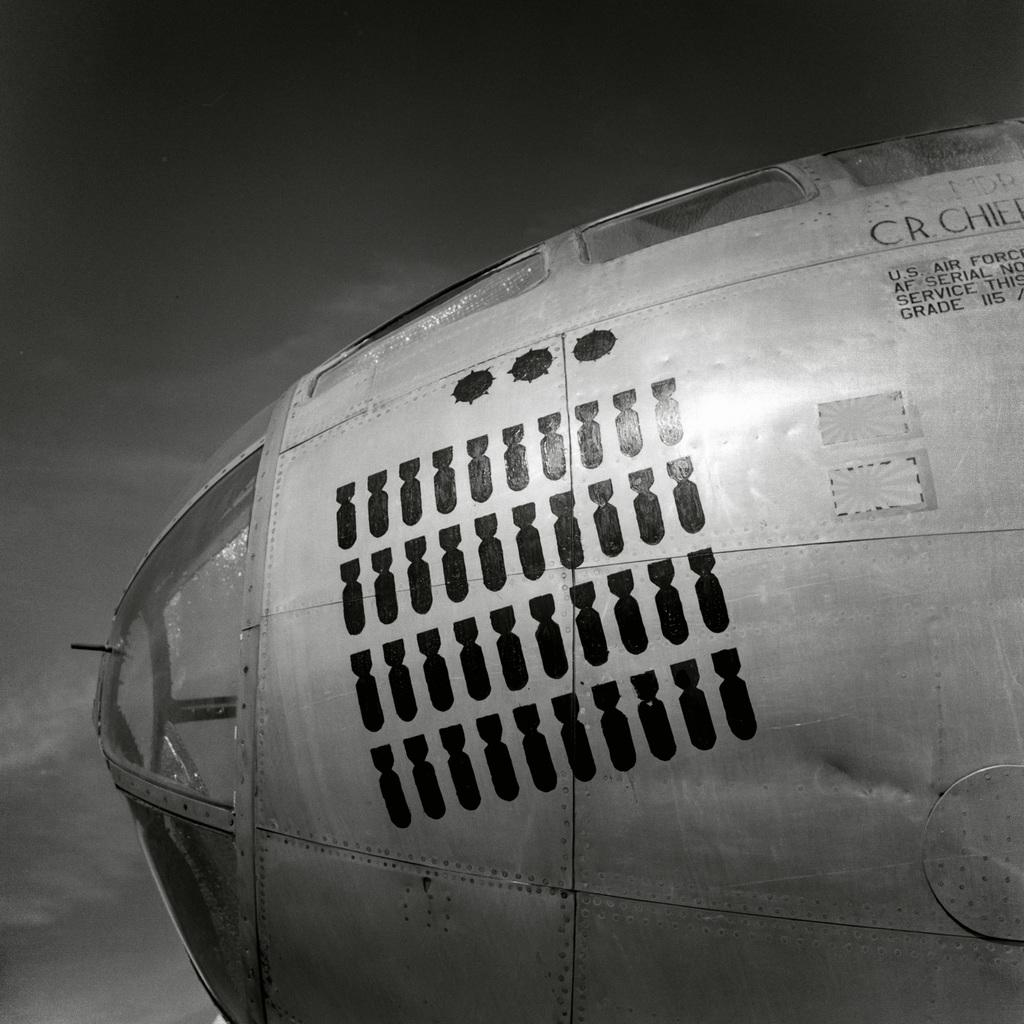What is the main subject of the image? There is an object in the image. Can you describe the object in the image? The object has writing on it. What is the color scheme of the image? The image is black and white in color. What can be seen in the background of the image? The sky is visible in the background of the image. What type of linen is being used to cover the object in the image? There is no linen present in the image, nor is any object being covered. 